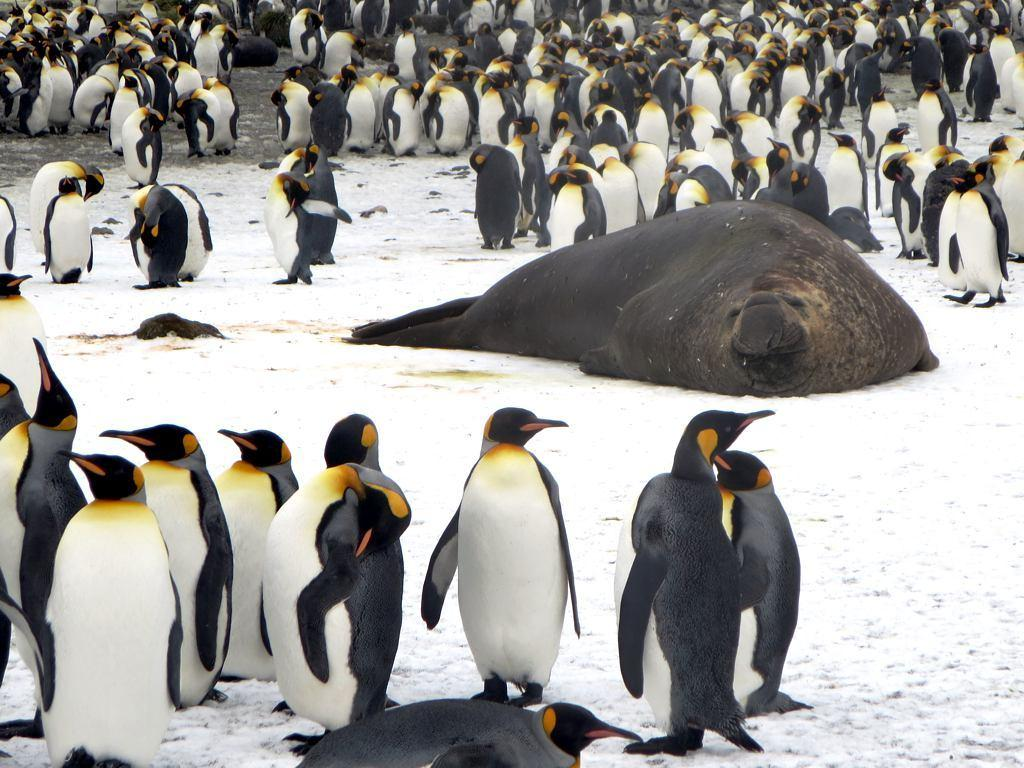What type of animals are present in the image? There is a group of penguins and a seal in the image. What is the location of the penguins and the seal in the image? Both the penguins and the seal are on the ground in the image. What type of pancake is being served at the camp in the image? There is no camp or pancake present in the image; it features a group of penguins and a seal on the ground. 